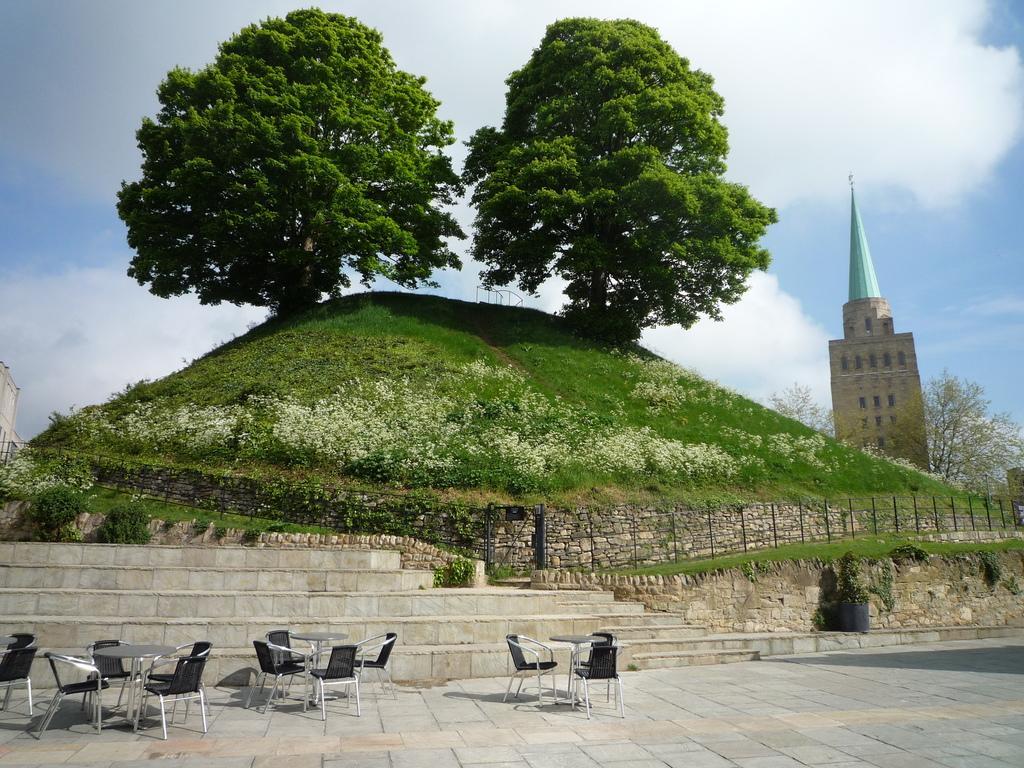What type of furniture can be seen in the image? There are chairs and tables in the image. What architectural feature is present in the image? There are steps in the image. What type of natural environment is visible in the image? There is grass in the image. What type of vegetation is present in the image? There are plants and trees in the image. What is visible on the wall in the image? There are flowers in the image. What type of structures can be seen in the image? There are buildings in the image. What is visible in the background of the image? The sky is visible in the background of the image, with clouds present. Can you tell me how many tails are visible on the dogs in the image? There are no dogs present in the image, so there are no tails to count. What type of loss is being experienced by the people in the image? There is no indication of any loss or sadness in the image; it features chairs, tables, steps, grass, plants, flowers, buildings, trees, and a sky with clouds. 